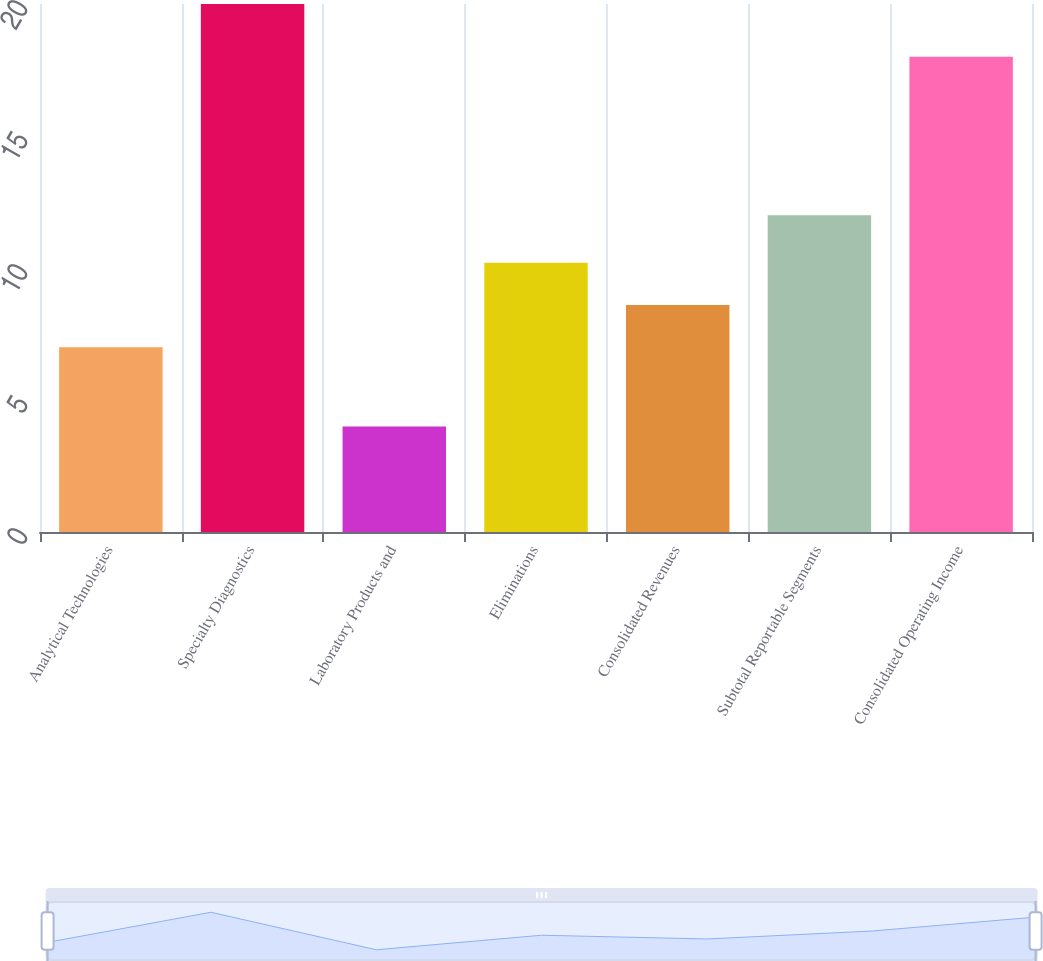<chart> <loc_0><loc_0><loc_500><loc_500><bar_chart><fcel>Analytical Technologies<fcel>Specialty Diagnostics<fcel>Laboratory Products and<fcel>Eliminations<fcel>Consolidated Revenues<fcel>Subtotal Reportable Segments<fcel>Consolidated Operating Income<nl><fcel>7<fcel>20<fcel>4<fcel>10.2<fcel>8.6<fcel>12<fcel>18<nl></chart> 